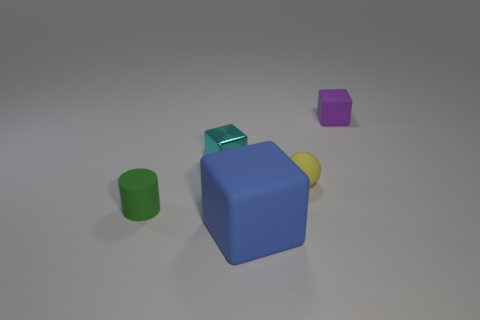Add 2 brown matte cylinders. How many objects exist? 7 Subtract all balls. How many objects are left? 4 Add 3 small yellow matte balls. How many small yellow matte balls exist? 4 Subtract 0 yellow cylinders. How many objects are left? 5 Subtract all metallic blocks. Subtract all big red rubber balls. How many objects are left? 4 Add 2 tiny yellow balls. How many tiny yellow balls are left? 3 